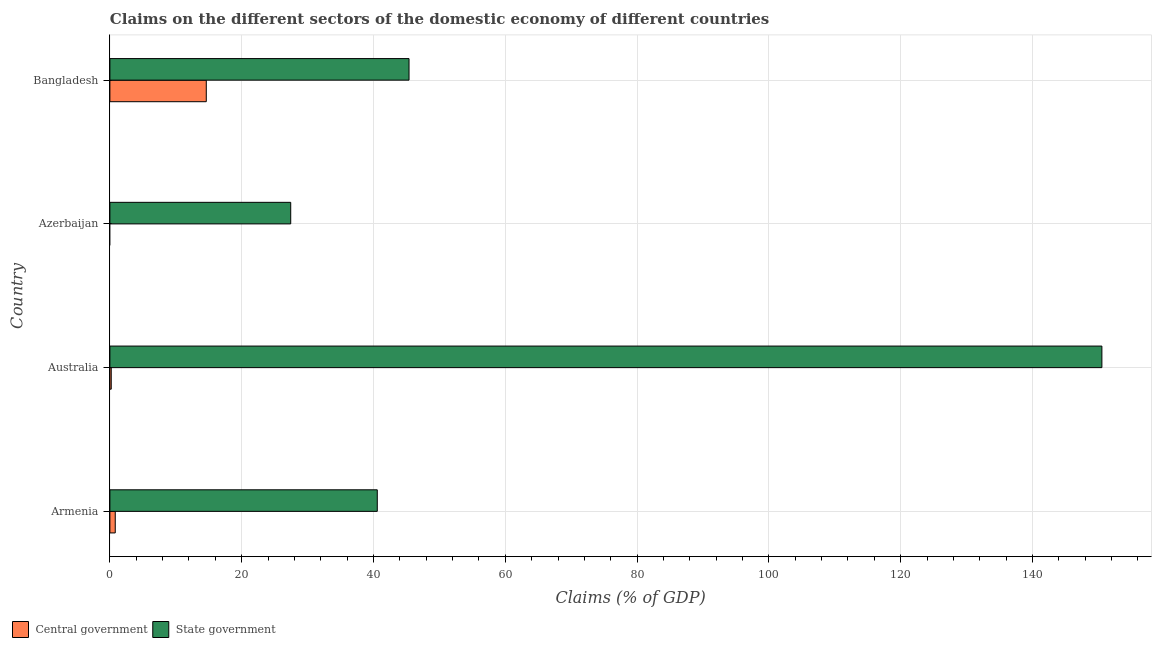Are the number of bars per tick equal to the number of legend labels?
Your answer should be very brief. No. Are the number of bars on each tick of the Y-axis equal?
Provide a succinct answer. No. How many bars are there on the 1st tick from the top?
Ensure brevity in your answer.  2. How many bars are there on the 2nd tick from the bottom?
Your answer should be compact. 2. What is the label of the 1st group of bars from the top?
Provide a short and direct response. Bangladesh. What is the claims on central government in Bangladesh?
Provide a succinct answer. 14.63. Across all countries, what is the maximum claims on state government?
Your response must be concise. 150.53. In which country was the claims on central government maximum?
Ensure brevity in your answer.  Bangladesh. What is the total claims on state government in the graph?
Offer a very short reply. 263.94. What is the difference between the claims on state government in Armenia and that in Australia?
Ensure brevity in your answer.  -109.96. What is the difference between the claims on state government in Australia and the claims on central government in Azerbaijan?
Your answer should be very brief. 150.53. What is the average claims on state government per country?
Offer a very short reply. 65.99. What is the difference between the claims on central government and claims on state government in Armenia?
Provide a short and direct response. -39.76. In how many countries, is the claims on central government greater than 44 %?
Offer a very short reply. 0. What is the ratio of the claims on state government in Azerbaijan to that in Bangladesh?
Make the answer very short. 0.6. Is the claims on state government in Armenia less than that in Bangladesh?
Your response must be concise. Yes. What is the difference between the highest and the second highest claims on central government?
Ensure brevity in your answer.  13.81. What is the difference between the highest and the lowest claims on state government?
Keep it short and to the point. 123.09. Are all the bars in the graph horizontal?
Provide a short and direct response. Yes. What is the difference between two consecutive major ticks on the X-axis?
Make the answer very short. 20. Are the values on the major ticks of X-axis written in scientific E-notation?
Keep it short and to the point. No. Does the graph contain any zero values?
Keep it short and to the point. Yes. Does the graph contain grids?
Your answer should be very brief. Yes. Where does the legend appear in the graph?
Your answer should be compact. Bottom left. What is the title of the graph?
Your response must be concise. Claims on the different sectors of the domestic economy of different countries. What is the label or title of the X-axis?
Offer a very short reply. Claims (% of GDP). What is the label or title of the Y-axis?
Your answer should be very brief. Country. What is the Claims (% of GDP) in Central government in Armenia?
Make the answer very short. 0.81. What is the Claims (% of GDP) of State government in Armenia?
Give a very brief answer. 40.57. What is the Claims (% of GDP) in Central government in Australia?
Your answer should be very brief. 0.2. What is the Claims (% of GDP) of State government in Australia?
Provide a short and direct response. 150.53. What is the Claims (% of GDP) of State government in Azerbaijan?
Offer a very short reply. 27.44. What is the Claims (% of GDP) in Central government in Bangladesh?
Ensure brevity in your answer.  14.63. What is the Claims (% of GDP) in State government in Bangladesh?
Ensure brevity in your answer.  45.39. Across all countries, what is the maximum Claims (% of GDP) of Central government?
Give a very brief answer. 14.63. Across all countries, what is the maximum Claims (% of GDP) of State government?
Offer a very short reply. 150.53. Across all countries, what is the minimum Claims (% of GDP) of Central government?
Your answer should be very brief. 0. Across all countries, what is the minimum Claims (% of GDP) of State government?
Your answer should be compact. 27.44. What is the total Claims (% of GDP) of Central government in the graph?
Your answer should be very brief. 15.64. What is the total Claims (% of GDP) of State government in the graph?
Keep it short and to the point. 263.94. What is the difference between the Claims (% of GDP) of Central government in Armenia and that in Australia?
Your response must be concise. 0.61. What is the difference between the Claims (% of GDP) in State government in Armenia and that in Australia?
Your answer should be very brief. -109.96. What is the difference between the Claims (% of GDP) in State government in Armenia and that in Azerbaijan?
Ensure brevity in your answer.  13.13. What is the difference between the Claims (% of GDP) of Central government in Armenia and that in Bangladesh?
Your answer should be compact. -13.81. What is the difference between the Claims (% of GDP) of State government in Armenia and that in Bangladesh?
Offer a terse response. -4.82. What is the difference between the Claims (% of GDP) in State government in Australia and that in Azerbaijan?
Your answer should be very brief. 123.09. What is the difference between the Claims (% of GDP) of Central government in Australia and that in Bangladesh?
Make the answer very short. -14.42. What is the difference between the Claims (% of GDP) in State government in Australia and that in Bangladesh?
Your response must be concise. 105.14. What is the difference between the Claims (% of GDP) of State government in Azerbaijan and that in Bangladesh?
Provide a short and direct response. -17.95. What is the difference between the Claims (% of GDP) in Central government in Armenia and the Claims (% of GDP) in State government in Australia?
Offer a terse response. -149.72. What is the difference between the Claims (% of GDP) of Central government in Armenia and the Claims (% of GDP) of State government in Azerbaijan?
Provide a succinct answer. -26.63. What is the difference between the Claims (% of GDP) of Central government in Armenia and the Claims (% of GDP) of State government in Bangladesh?
Make the answer very short. -44.58. What is the difference between the Claims (% of GDP) in Central government in Australia and the Claims (% of GDP) in State government in Azerbaijan?
Your response must be concise. -27.24. What is the difference between the Claims (% of GDP) in Central government in Australia and the Claims (% of GDP) in State government in Bangladesh?
Offer a terse response. -45.19. What is the average Claims (% of GDP) in Central government per country?
Ensure brevity in your answer.  3.91. What is the average Claims (% of GDP) of State government per country?
Your answer should be compact. 65.99. What is the difference between the Claims (% of GDP) in Central government and Claims (% of GDP) in State government in Armenia?
Ensure brevity in your answer.  -39.76. What is the difference between the Claims (% of GDP) in Central government and Claims (% of GDP) in State government in Australia?
Your answer should be very brief. -150.33. What is the difference between the Claims (% of GDP) in Central government and Claims (% of GDP) in State government in Bangladesh?
Your answer should be compact. -30.77. What is the ratio of the Claims (% of GDP) in Central government in Armenia to that in Australia?
Keep it short and to the point. 4.01. What is the ratio of the Claims (% of GDP) in State government in Armenia to that in Australia?
Offer a terse response. 0.27. What is the ratio of the Claims (% of GDP) in State government in Armenia to that in Azerbaijan?
Offer a terse response. 1.48. What is the ratio of the Claims (% of GDP) of Central government in Armenia to that in Bangladesh?
Your response must be concise. 0.06. What is the ratio of the Claims (% of GDP) of State government in Armenia to that in Bangladesh?
Your response must be concise. 0.89. What is the ratio of the Claims (% of GDP) in State government in Australia to that in Azerbaijan?
Your response must be concise. 5.49. What is the ratio of the Claims (% of GDP) of Central government in Australia to that in Bangladesh?
Ensure brevity in your answer.  0.01. What is the ratio of the Claims (% of GDP) of State government in Australia to that in Bangladesh?
Provide a short and direct response. 3.32. What is the ratio of the Claims (% of GDP) in State government in Azerbaijan to that in Bangladesh?
Keep it short and to the point. 0.6. What is the difference between the highest and the second highest Claims (% of GDP) in Central government?
Provide a short and direct response. 13.81. What is the difference between the highest and the second highest Claims (% of GDP) in State government?
Your answer should be compact. 105.14. What is the difference between the highest and the lowest Claims (% of GDP) in Central government?
Make the answer very short. 14.63. What is the difference between the highest and the lowest Claims (% of GDP) of State government?
Give a very brief answer. 123.09. 